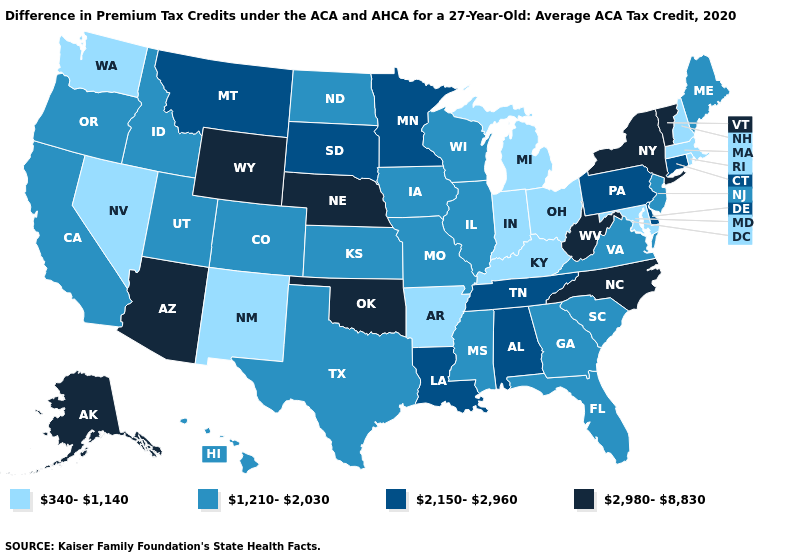What is the value of Louisiana?
Keep it brief. 2,150-2,960. Name the states that have a value in the range 2,150-2,960?
Quick response, please. Alabama, Connecticut, Delaware, Louisiana, Minnesota, Montana, Pennsylvania, South Dakota, Tennessee. What is the lowest value in the USA?
Keep it brief. 340-1,140. What is the value of Wisconsin?
Be succinct. 1,210-2,030. What is the value of Rhode Island?
Keep it brief. 340-1,140. What is the value of Alaska?
Keep it brief. 2,980-8,830. Does the map have missing data?
Be succinct. No. Does West Virginia have the highest value in the South?
Concise answer only. Yes. Which states have the lowest value in the South?
Give a very brief answer. Arkansas, Kentucky, Maryland. Does Alaska have the highest value in the USA?
Concise answer only. Yes. What is the highest value in the USA?
Concise answer only. 2,980-8,830. Is the legend a continuous bar?
Quick response, please. No. Name the states that have a value in the range 2,980-8,830?
Quick response, please. Alaska, Arizona, Nebraska, New York, North Carolina, Oklahoma, Vermont, West Virginia, Wyoming. How many symbols are there in the legend?
Answer briefly. 4. Does Alaska have the same value as West Virginia?
Concise answer only. Yes. 